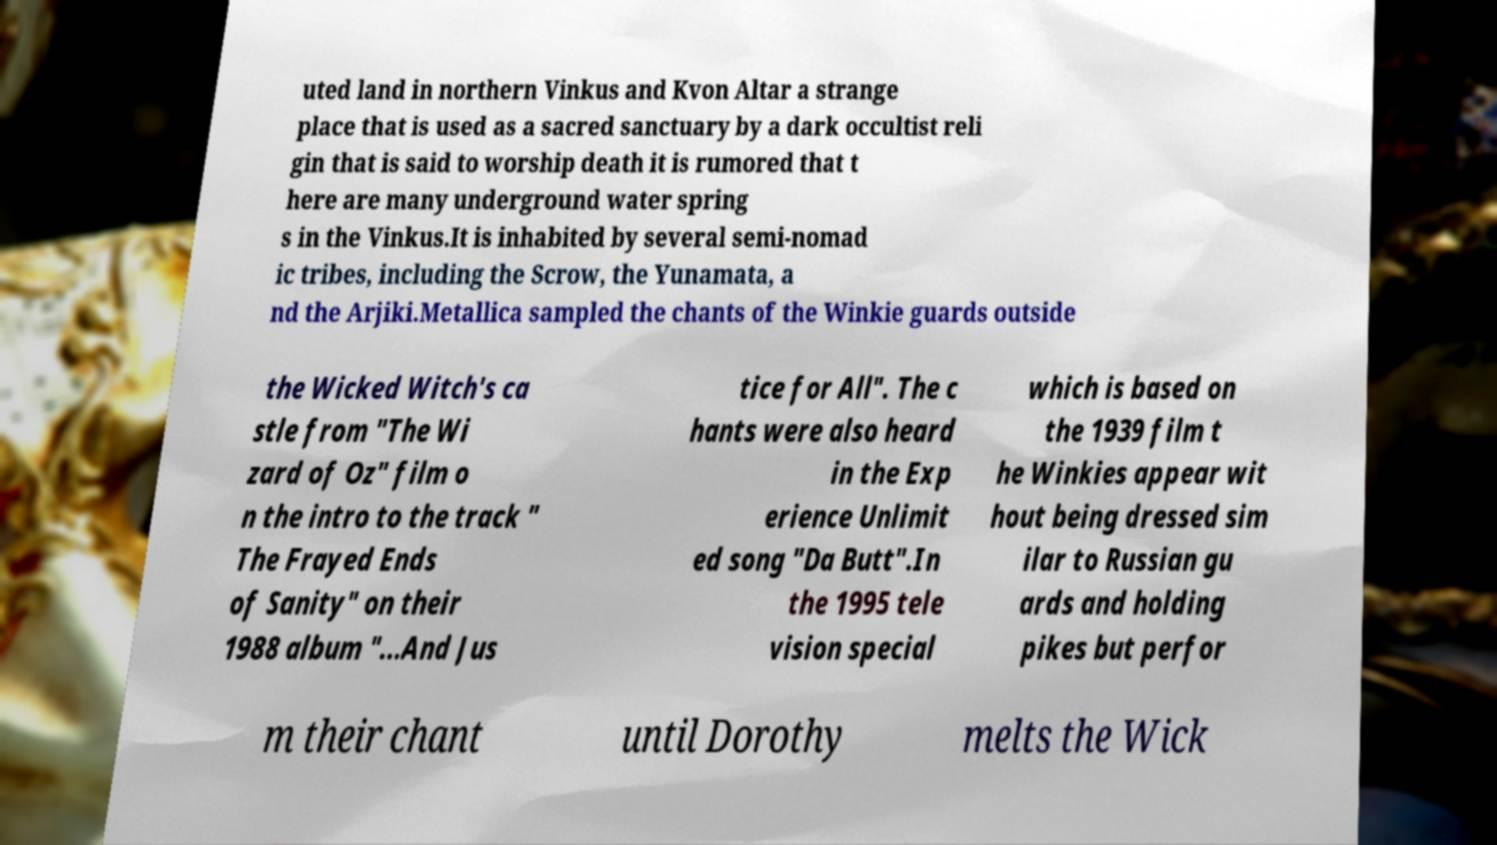There's text embedded in this image that I need extracted. Can you transcribe it verbatim? uted land in northern Vinkus and Kvon Altar a strange place that is used as a sacred sanctuary by a dark occultist reli gin that is said to worship death it is rumored that t here are many underground water spring s in the Vinkus.It is inhabited by several semi-nomad ic tribes, including the Scrow, the Yunamata, a nd the Arjiki.Metallica sampled the chants of the Winkie guards outside the Wicked Witch's ca stle from "The Wi zard of Oz" film o n the intro to the track " The Frayed Ends of Sanity" on their 1988 album "...And Jus tice for All". The c hants were also heard in the Exp erience Unlimit ed song "Da Butt".In the 1995 tele vision special which is based on the 1939 film t he Winkies appear wit hout being dressed sim ilar to Russian gu ards and holding pikes but perfor m their chant until Dorothy melts the Wick 